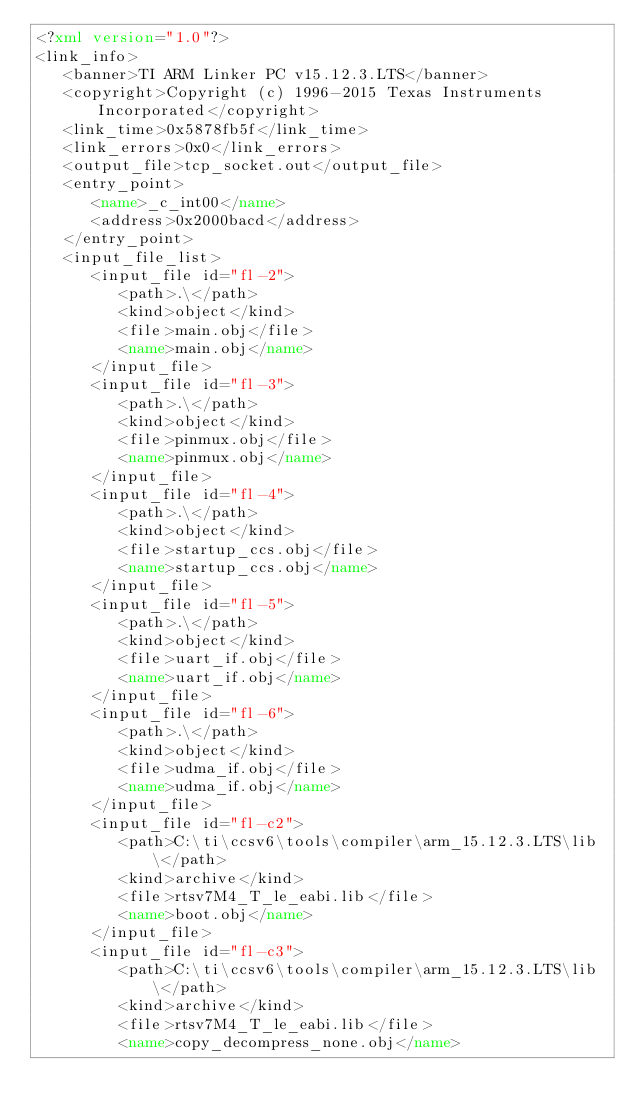<code> <loc_0><loc_0><loc_500><loc_500><_XML_><?xml version="1.0"?>
<link_info>
   <banner>TI ARM Linker PC v15.12.3.LTS</banner>
   <copyright>Copyright (c) 1996-2015 Texas Instruments Incorporated</copyright>
   <link_time>0x5878fb5f</link_time>
   <link_errors>0x0</link_errors>
   <output_file>tcp_socket.out</output_file>
   <entry_point>
      <name>_c_int00</name>
      <address>0x2000bacd</address>
   </entry_point>
   <input_file_list>
      <input_file id="fl-2">
         <path>.\</path>
         <kind>object</kind>
         <file>main.obj</file>
         <name>main.obj</name>
      </input_file>
      <input_file id="fl-3">
         <path>.\</path>
         <kind>object</kind>
         <file>pinmux.obj</file>
         <name>pinmux.obj</name>
      </input_file>
      <input_file id="fl-4">
         <path>.\</path>
         <kind>object</kind>
         <file>startup_ccs.obj</file>
         <name>startup_ccs.obj</name>
      </input_file>
      <input_file id="fl-5">
         <path>.\</path>
         <kind>object</kind>
         <file>uart_if.obj</file>
         <name>uart_if.obj</name>
      </input_file>
      <input_file id="fl-6">
         <path>.\</path>
         <kind>object</kind>
         <file>udma_if.obj</file>
         <name>udma_if.obj</name>
      </input_file>
      <input_file id="fl-c2">
         <path>C:\ti\ccsv6\tools\compiler\arm_15.12.3.LTS\lib\</path>
         <kind>archive</kind>
         <file>rtsv7M4_T_le_eabi.lib</file>
         <name>boot.obj</name>
      </input_file>
      <input_file id="fl-c3">
         <path>C:\ti\ccsv6\tools\compiler\arm_15.12.3.LTS\lib\</path>
         <kind>archive</kind>
         <file>rtsv7M4_T_le_eabi.lib</file>
         <name>copy_decompress_none.obj</name></code> 